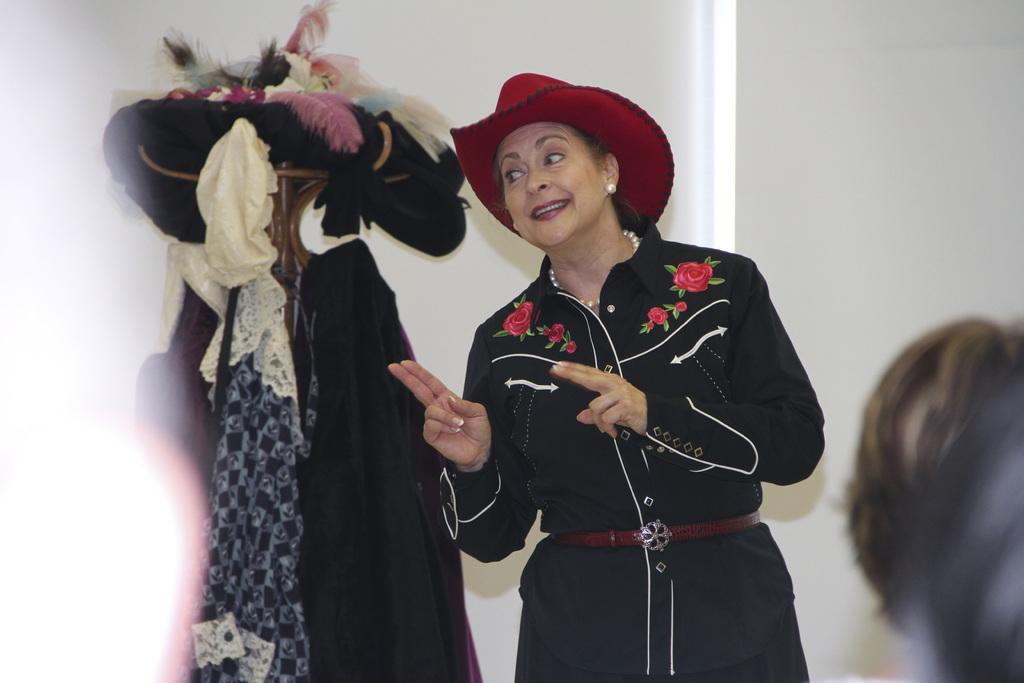Who is present in the image? There is a woman in the image. What is the woman doing in the image? The woman is standing in the image. What is the woman wearing on her head? The woman is wearing a hat in the image. What can be seen on the stand in the image? There are clothes and other objects on the stand in the image. What is visible in the background of the image? There is a wall visible in the image. What question is the woman asking in the image? There is no indication in the image that the woman is asking a question. 